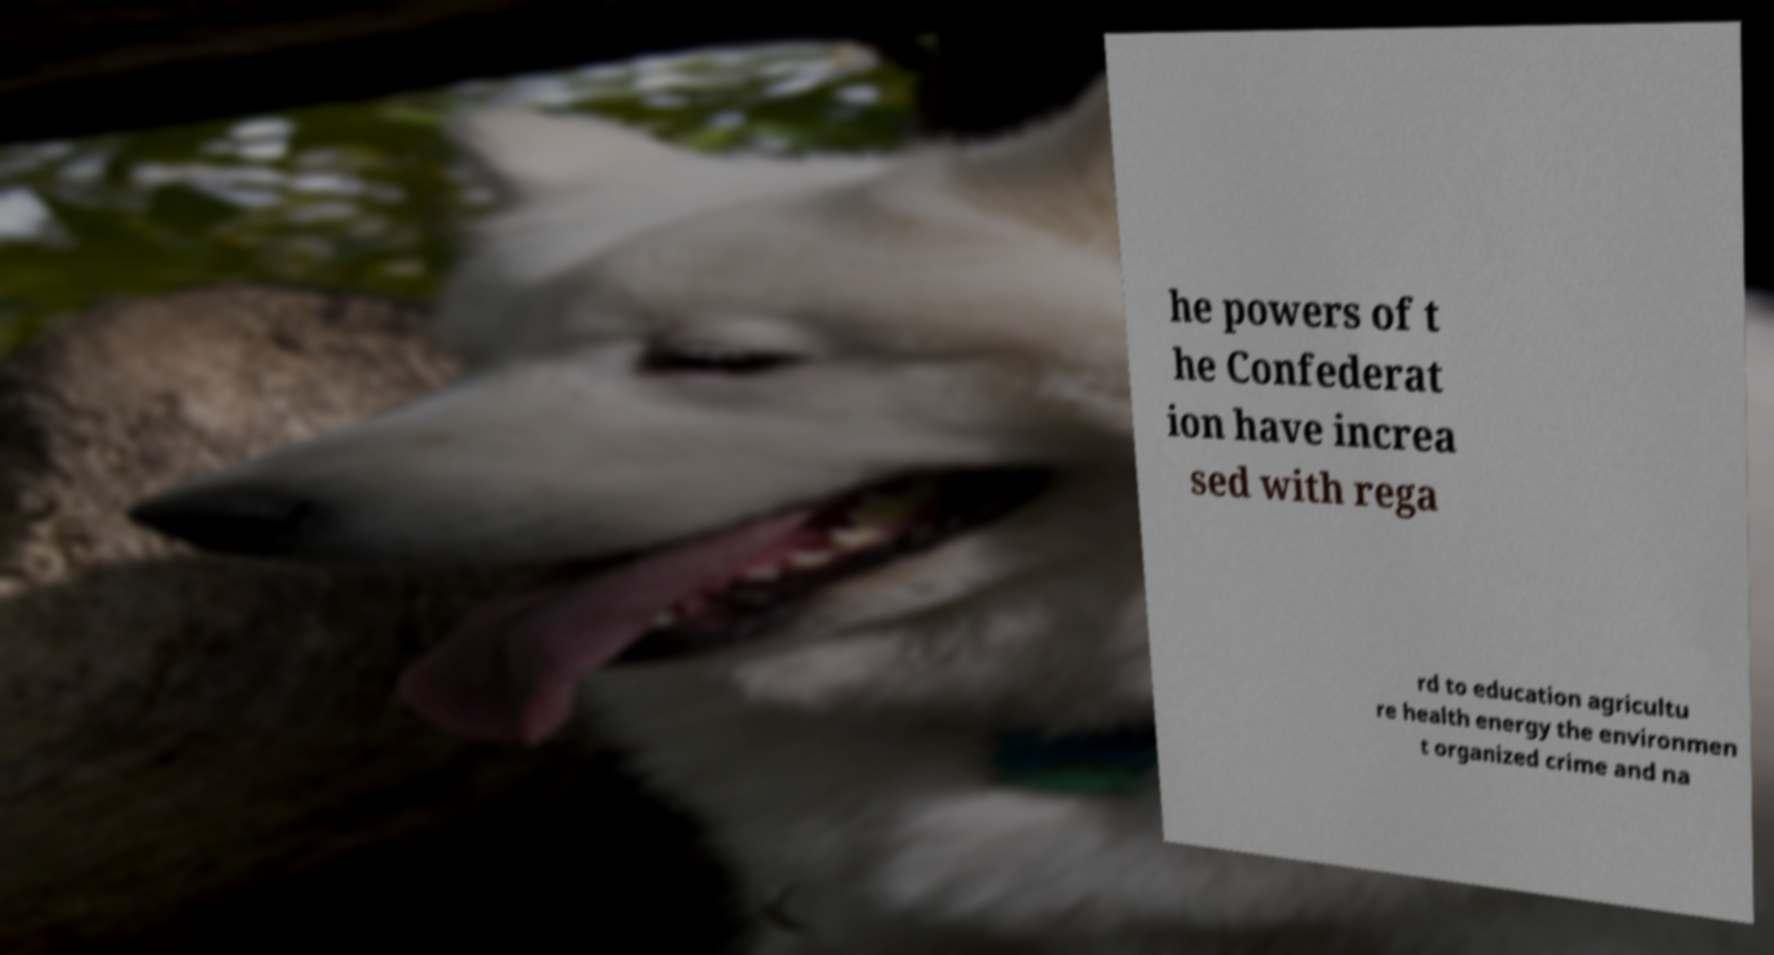For documentation purposes, I need the text within this image transcribed. Could you provide that? he powers of t he Confederat ion have increa sed with rega rd to education agricultu re health energy the environmen t organized crime and na 